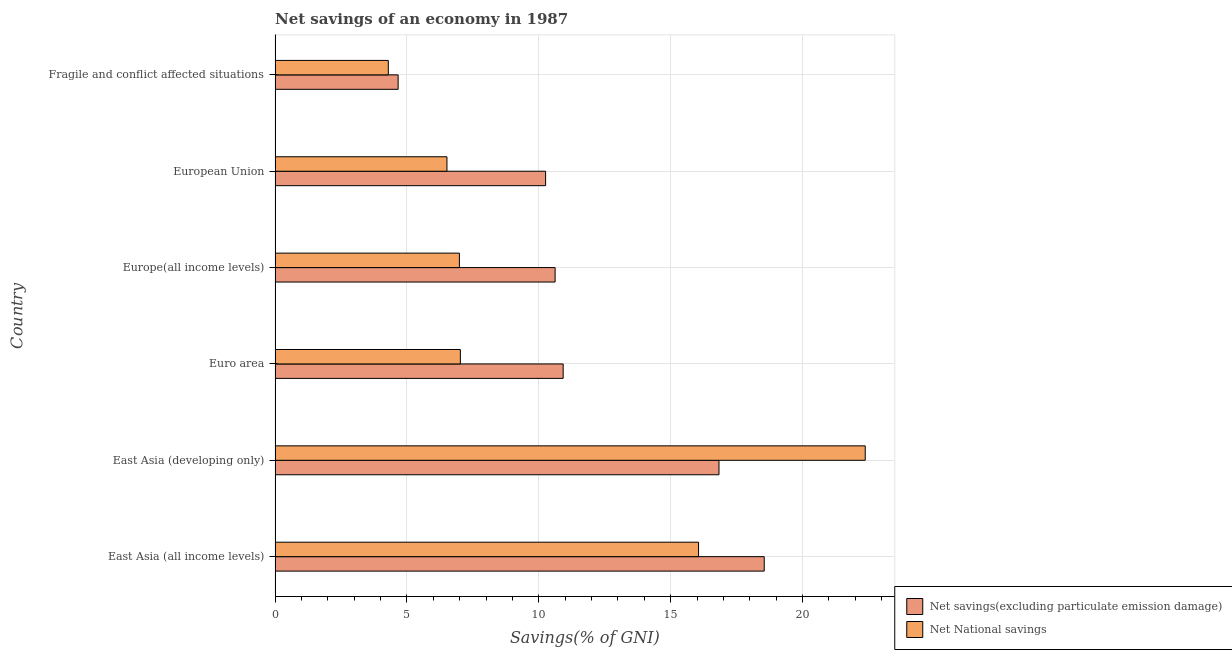How many groups of bars are there?
Ensure brevity in your answer.  6. How many bars are there on the 4th tick from the top?
Keep it short and to the point. 2. How many bars are there on the 3rd tick from the bottom?
Your answer should be compact. 2. What is the label of the 2nd group of bars from the top?
Give a very brief answer. European Union. What is the net national savings in Europe(all income levels)?
Provide a short and direct response. 6.99. Across all countries, what is the maximum net national savings?
Offer a terse response. 22.38. Across all countries, what is the minimum net savings(excluding particulate emission damage)?
Provide a succinct answer. 4.67. In which country was the net national savings maximum?
Ensure brevity in your answer.  East Asia (developing only). In which country was the net savings(excluding particulate emission damage) minimum?
Offer a terse response. Fragile and conflict affected situations. What is the total net savings(excluding particulate emission damage) in the graph?
Your answer should be compact. 71.84. What is the difference between the net national savings in East Asia (developing only) and that in European Union?
Make the answer very short. 15.86. What is the difference between the net national savings in East Asia (developing only) and the net savings(excluding particulate emission damage) in European Union?
Offer a terse response. 12.12. What is the average net national savings per country?
Ensure brevity in your answer.  10.54. What is the difference between the net national savings and net savings(excluding particulate emission damage) in Fragile and conflict affected situations?
Your answer should be very brief. -0.37. In how many countries, is the net savings(excluding particulate emission damage) greater than 18 %?
Keep it short and to the point. 1. What is the ratio of the net savings(excluding particulate emission damage) in East Asia (all income levels) to that in Fragile and conflict affected situations?
Give a very brief answer. 3.98. Is the net savings(excluding particulate emission damage) in East Asia (all income levels) less than that in Euro area?
Your answer should be very brief. No. Is the difference between the net national savings in East Asia (developing only) and Euro area greater than the difference between the net savings(excluding particulate emission damage) in East Asia (developing only) and Euro area?
Your answer should be compact. Yes. What is the difference between the highest and the second highest net savings(excluding particulate emission damage)?
Your answer should be very brief. 1.72. What is the difference between the highest and the lowest net national savings?
Make the answer very short. 18.08. Is the sum of the net savings(excluding particulate emission damage) in East Asia (all income levels) and Europe(all income levels) greater than the maximum net national savings across all countries?
Keep it short and to the point. Yes. What does the 1st bar from the top in East Asia (all income levels) represents?
Offer a very short reply. Net National savings. What does the 1st bar from the bottom in Euro area represents?
Offer a terse response. Net savings(excluding particulate emission damage). How many countries are there in the graph?
Ensure brevity in your answer.  6. What is the difference between two consecutive major ticks on the X-axis?
Offer a very short reply. 5. Are the values on the major ticks of X-axis written in scientific E-notation?
Your response must be concise. No. Does the graph contain any zero values?
Your response must be concise. No. Does the graph contain grids?
Make the answer very short. Yes. Where does the legend appear in the graph?
Provide a succinct answer. Bottom right. How many legend labels are there?
Your answer should be compact. 2. What is the title of the graph?
Give a very brief answer. Net savings of an economy in 1987. What is the label or title of the X-axis?
Provide a succinct answer. Savings(% of GNI). What is the label or title of the Y-axis?
Give a very brief answer. Country. What is the Savings(% of GNI) of Net savings(excluding particulate emission damage) in East Asia (all income levels)?
Your answer should be very brief. 18.55. What is the Savings(% of GNI) of Net National savings in East Asia (all income levels)?
Your answer should be very brief. 16.06. What is the Savings(% of GNI) in Net savings(excluding particulate emission damage) in East Asia (developing only)?
Ensure brevity in your answer.  16.83. What is the Savings(% of GNI) in Net National savings in East Asia (developing only)?
Offer a very short reply. 22.38. What is the Savings(% of GNI) of Net savings(excluding particulate emission damage) in Euro area?
Provide a short and direct response. 10.92. What is the Savings(% of GNI) of Net National savings in Euro area?
Ensure brevity in your answer.  7.02. What is the Savings(% of GNI) in Net savings(excluding particulate emission damage) in Europe(all income levels)?
Ensure brevity in your answer.  10.62. What is the Savings(% of GNI) of Net National savings in Europe(all income levels)?
Your answer should be very brief. 6.99. What is the Savings(% of GNI) in Net savings(excluding particulate emission damage) in European Union?
Your answer should be very brief. 10.26. What is the Savings(% of GNI) of Net National savings in European Union?
Keep it short and to the point. 6.52. What is the Savings(% of GNI) in Net savings(excluding particulate emission damage) in Fragile and conflict affected situations?
Give a very brief answer. 4.67. What is the Savings(% of GNI) of Net National savings in Fragile and conflict affected situations?
Keep it short and to the point. 4.29. Across all countries, what is the maximum Savings(% of GNI) in Net savings(excluding particulate emission damage)?
Make the answer very short. 18.55. Across all countries, what is the maximum Savings(% of GNI) in Net National savings?
Your answer should be compact. 22.38. Across all countries, what is the minimum Savings(% of GNI) in Net savings(excluding particulate emission damage)?
Offer a very short reply. 4.67. Across all countries, what is the minimum Savings(% of GNI) in Net National savings?
Keep it short and to the point. 4.29. What is the total Savings(% of GNI) in Net savings(excluding particulate emission damage) in the graph?
Your response must be concise. 71.84. What is the total Savings(% of GNI) of Net National savings in the graph?
Offer a terse response. 63.25. What is the difference between the Savings(% of GNI) in Net savings(excluding particulate emission damage) in East Asia (all income levels) and that in East Asia (developing only)?
Give a very brief answer. 1.72. What is the difference between the Savings(% of GNI) of Net National savings in East Asia (all income levels) and that in East Asia (developing only)?
Your answer should be very brief. -6.32. What is the difference between the Savings(% of GNI) of Net savings(excluding particulate emission damage) in East Asia (all income levels) and that in Euro area?
Provide a short and direct response. 7.62. What is the difference between the Savings(% of GNI) in Net National savings in East Asia (all income levels) and that in Euro area?
Provide a short and direct response. 9.03. What is the difference between the Savings(% of GNI) of Net savings(excluding particulate emission damage) in East Asia (all income levels) and that in Europe(all income levels)?
Keep it short and to the point. 7.93. What is the difference between the Savings(% of GNI) of Net National savings in East Asia (all income levels) and that in Europe(all income levels)?
Offer a terse response. 9.07. What is the difference between the Savings(% of GNI) in Net savings(excluding particulate emission damage) in East Asia (all income levels) and that in European Union?
Your response must be concise. 8.29. What is the difference between the Savings(% of GNI) in Net National savings in East Asia (all income levels) and that in European Union?
Your response must be concise. 9.54. What is the difference between the Savings(% of GNI) of Net savings(excluding particulate emission damage) in East Asia (all income levels) and that in Fragile and conflict affected situations?
Your answer should be very brief. 13.88. What is the difference between the Savings(% of GNI) of Net National savings in East Asia (all income levels) and that in Fragile and conflict affected situations?
Offer a very short reply. 11.76. What is the difference between the Savings(% of GNI) in Net savings(excluding particulate emission damage) in East Asia (developing only) and that in Euro area?
Make the answer very short. 5.91. What is the difference between the Savings(% of GNI) in Net National savings in East Asia (developing only) and that in Euro area?
Your answer should be compact. 15.35. What is the difference between the Savings(% of GNI) of Net savings(excluding particulate emission damage) in East Asia (developing only) and that in Europe(all income levels)?
Offer a terse response. 6.21. What is the difference between the Savings(% of GNI) of Net National savings in East Asia (developing only) and that in Europe(all income levels)?
Provide a short and direct response. 15.39. What is the difference between the Savings(% of GNI) in Net savings(excluding particulate emission damage) in East Asia (developing only) and that in European Union?
Ensure brevity in your answer.  6.57. What is the difference between the Savings(% of GNI) of Net National savings in East Asia (developing only) and that in European Union?
Your response must be concise. 15.86. What is the difference between the Savings(% of GNI) in Net savings(excluding particulate emission damage) in East Asia (developing only) and that in Fragile and conflict affected situations?
Your answer should be compact. 12.17. What is the difference between the Savings(% of GNI) in Net National savings in East Asia (developing only) and that in Fragile and conflict affected situations?
Provide a succinct answer. 18.08. What is the difference between the Savings(% of GNI) in Net savings(excluding particulate emission damage) in Euro area and that in Europe(all income levels)?
Provide a succinct answer. 0.31. What is the difference between the Savings(% of GNI) in Net National savings in Euro area and that in Europe(all income levels)?
Your answer should be very brief. 0.04. What is the difference between the Savings(% of GNI) in Net savings(excluding particulate emission damage) in Euro area and that in European Union?
Offer a terse response. 0.67. What is the difference between the Savings(% of GNI) of Net National savings in Euro area and that in European Union?
Keep it short and to the point. 0.51. What is the difference between the Savings(% of GNI) of Net savings(excluding particulate emission damage) in Euro area and that in Fragile and conflict affected situations?
Offer a very short reply. 6.26. What is the difference between the Savings(% of GNI) of Net National savings in Euro area and that in Fragile and conflict affected situations?
Keep it short and to the point. 2.73. What is the difference between the Savings(% of GNI) in Net savings(excluding particulate emission damage) in Europe(all income levels) and that in European Union?
Offer a very short reply. 0.36. What is the difference between the Savings(% of GNI) of Net National savings in Europe(all income levels) and that in European Union?
Provide a succinct answer. 0.47. What is the difference between the Savings(% of GNI) in Net savings(excluding particulate emission damage) in Europe(all income levels) and that in Fragile and conflict affected situations?
Your answer should be very brief. 5.95. What is the difference between the Savings(% of GNI) in Net National savings in Europe(all income levels) and that in Fragile and conflict affected situations?
Give a very brief answer. 2.7. What is the difference between the Savings(% of GNI) in Net savings(excluding particulate emission damage) in European Union and that in Fragile and conflict affected situations?
Provide a short and direct response. 5.59. What is the difference between the Savings(% of GNI) of Net National savings in European Union and that in Fragile and conflict affected situations?
Offer a very short reply. 2.22. What is the difference between the Savings(% of GNI) in Net savings(excluding particulate emission damage) in East Asia (all income levels) and the Savings(% of GNI) in Net National savings in East Asia (developing only)?
Provide a succinct answer. -3.83. What is the difference between the Savings(% of GNI) of Net savings(excluding particulate emission damage) in East Asia (all income levels) and the Savings(% of GNI) of Net National savings in Euro area?
Provide a succinct answer. 11.52. What is the difference between the Savings(% of GNI) of Net savings(excluding particulate emission damage) in East Asia (all income levels) and the Savings(% of GNI) of Net National savings in Europe(all income levels)?
Provide a short and direct response. 11.56. What is the difference between the Savings(% of GNI) of Net savings(excluding particulate emission damage) in East Asia (all income levels) and the Savings(% of GNI) of Net National savings in European Union?
Your response must be concise. 12.03. What is the difference between the Savings(% of GNI) of Net savings(excluding particulate emission damage) in East Asia (all income levels) and the Savings(% of GNI) of Net National savings in Fragile and conflict affected situations?
Offer a very short reply. 14.25. What is the difference between the Savings(% of GNI) of Net savings(excluding particulate emission damage) in East Asia (developing only) and the Savings(% of GNI) of Net National savings in Euro area?
Make the answer very short. 9.81. What is the difference between the Savings(% of GNI) in Net savings(excluding particulate emission damage) in East Asia (developing only) and the Savings(% of GNI) in Net National savings in Europe(all income levels)?
Provide a succinct answer. 9.84. What is the difference between the Savings(% of GNI) of Net savings(excluding particulate emission damage) in East Asia (developing only) and the Savings(% of GNI) of Net National savings in European Union?
Offer a very short reply. 10.31. What is the difference between the Savings(% of GNI) in Net savings(excluding particulate emission damage) in East Asia (developing only) and the Savings(% of GNI) in Net National savings in Fragile and conflict affected situations?
Offer a terse response. 12.54. What is the difference between the Savings(% of GNI) in Net savings(excluding particulate emission damage) in Euro area and the Savings(% of GNI) in Net National savings in Europe(all income levels)?
Ensure brevity in your answer.  3.93. What is the difference between the Savings(% of GNI) of Net savings(excluding particulate emission damage) in Euro area and the Savings(% of GNI) of Net National savings in European Union?
Your answer should be compact. 4.41. What is the difference between the Savings(% of GNI) of Net savings(excluding particulate emission damage) in Euro area and the Savings(% of GNI) of Net National savings in Fragile and conflict affected situations?
Your answer should be compact. 6.63. What is the difference between the Savings(% of GNI) of Net savings(excluding particulate emission damage) in Europe(all income levels) and the Savings(% of GNI) of Net National savings in European Union?
Your answer should be compact. 4.1. What is the difference between the Savings(% of GNI) of Net savings(excluding particulate emission damage) in Europe(all income levels) and the Savings(% of GNI) of Net National savings in Fragile and conflict affected situations?
Your response must be concise. 6.32. What is the difference between the Savings(% of GNI) in Net savings(excluding particulate emission damage) in European Union and the Savings(% of GNI) in Net National savings in Fragile and conflict affected situations?
Ensure brevity in your answer.  5.96. What is the average Savings(% of GNI) of Net savings(excluding particulate emission damage) per country?
Your answer should be compact. 11.97. What is the average Savings(% of GNI) of Net National savings per country?
Keep it short and to the point. 10.54. What is the difference between the Savings(% of GNI) of Net savings(excluding particulate emission damage) and Savings(% of GNI) of Net National savings in East Asia (all income levels)?
Keep it short and to the point. 2.49. What is the difference between the Savings(% of GNI) in Net savings(excluding particulate emission damage) and Savings(% of GNI) in Net National savings in East Asia (developing only)?
Your answer should be compact. -5.54. What is the difference between the Savings(% of GNI) of Net savings(excluding particulate emission damage) and Savings(% of GNI) of Net National savings in Euro area?
Offer a terse response. 3.9. What is the difference between the Savings(% of GNI) in Net savings(excluding particulate emission damage) and Savings(% of GNI) in Net National savings in Europe(all income levels)?
Give a very brief answer. 3.63. What is the difference between the Savings(% of GNI) in Net savings(excluding particulate emission damage) and Savings(% of GNI) in Net National savings in European Union?
Make the answer very short. 3.74. What is the difference between the Savings(% of GNI) in Net savings(excluding particulate emission damage) and Savings(% of GNI) in Net National savings in Fragile and conflict affected situations?
Your answer should be compact. 0.37. What is the ratio of the Savings(% of GNI) of Net savings(excluding particulate emission damage) in East Asia (all income levels) to that in East Asia (developing only)?
Keep it short and to the point. 1.1. What is the ratio of the Savings(% of GNI) of Net National savings in East Asia (all income levels) to that in East Asia (developing only)?
Offer a very short reply. 0.72. What is the ratio of the Savings(% of GNI) of Net savings(excluding particulate emission damage) in East Asia (all income levels) to that in Euro area?
Your answer should be compact. 1.7. What is the ratio of the Savings(% of GNI) in Net National savings in East Asia (all income levels) to that in Euro area?
Ensure brevity in your answer.  2.29. What is the ratio of the Savings(% of GNI) in Net savings(excluding particulate emission damage) in East Asia (all income levels) to that in Europe(all income levels)?
Make the answer very short. 1.75. What is the ratio of the Savings(% of GNI) of Net National savings in East Asia (all income levels) to that in Europe(all income levels)?
Keep it short and to the point. 2.3. What is the ratio of the Savings(% of GNI) in Net savings(excluding particulate emission damage) in East Asia (all income levels) to that in European Union?
Your answer should be compact. 1.81. What is the ratio of the Savings(% of GNI) of Net National savings in East Asia (all income levels) to that in European Union?
Ensure brevity in your answer.  2.46. What is the ratio of the Savings(% of GNI) of Net savings(excluding particulate emission damage) in East Asia (all income levels) to that in Fragile and conflict affected situations?
Make the answer very short. 3.98. What is the ratio of the Savings(% of GNI) in Net National savings in East Asia (all income levels) to that in Fragile and conflict affected situations?
Offer a terse response. 3.74. What is the ratio of the Savings(% of GNI) of Net savings(excluding particulate emission damage) in East Asia (developing only) to that in Euro area?
Your answer should be very brief. 1.54. What is the ratio of the Savings(% of GNI) of Net National savings in East Asia (developing only) to that in Euro area?
Your answer should be very brief. 3.19. What is the ratio of the Savings(% of GNI) in Net savings(excluding particulate emission damage) in East Asia (developing only) to that in Europe(all income levels)?
Ensure brevity in your answer.  1.59. What is the ratio of the Savings(% of GNI) of Net National savings in East Asia (developing only) to that in Europe(all income levels)?
Offer a terse response. 3.2. What is the ratio of the Savings(% of GNI) in Net savings(excluding particulate emission damage) in East Asia (developing only) to that in European Union?
Your response must be concise. 1.64. What is the ratio of the Savings(% of GNI) of Net National savings in East Asia (developing only) to that in European Union?
Give a very brief answer. 3.43. What is the ratio of the Savings(% of GNI) in Net savings(excluding particulate emission damage) in East Asia (developing only) to that in Fragile and conflict affected situations?
Your answer should be compact. 3.61. What is the ratio of the Savings(% of GNI) in Net National savings in East Asia (developing only) to that in Fragile and conflict affected situations?
Offer a terse response. 5.21. What is the ratio of the Savings(% of GNI) of Net savings(excluding particulate emission damage) in Euro area to that in Europe(all income levels)?
Your answer should be very brief. 1.03. What is the ratio of the Savings(% of GNI) of Net savings(excluding particulate emission damage) in Euro area to that in European Union?
Offer a terse response. 1.06. What is the ratio of the Savings(% of GNI) of Net National savings in Euro area to that in European Union?
Your response must be concise. 1.08. What is the ratio of the Savings(% of GNI) of Net savings(excluding particulate emission damage) in Euro area to that in Fragile and conflict affected situations?
Offer a very short reply. 2.34. What is the ratio of the Savings(% of GNI) of Net National savings in Euro area to that in Fragile and conflict affected situations?
Your answer should be compact. 1.64. What is the ratio of the Savings(% of GNI) in Net savings(excluding particulate emission damage) in Europe(all income levels) to that in European Union?
Your answer should be very brief. 1.04. What is the ratio of the Savings(% of GNI) of Net National savings in Europe(all income levels) to that in European Union?
Make the answer very short. 1.07. What is the ratio of the Savings(% of GNI) in Net savings(excluding particulate emission damage) in Europe(all income levels) to that in Fragile and conflict affected situations?
Provide a short and direct response. 2.28. What is the ratio of the Savings(% of GNI) in Net National savings in Europe(all income levels) to that in Fragile and conflict affected situations?
Your answer should be very brief. 1.63. What is the ratio of the Savings(% of GNI) in Net savings(excluding particulate emission damage) in European Union to that in Fragile and conflict affected situations?
Provide a succinct answer. 2.2. What is the ratio of the Savings(% of GNI) in Net National savings in European Union to that in Fragile and conflict affected situations?
Make the answer very short. 1.52. What is the difference between the highest and the second highest Savings(% of GNI) in Net savings(excluding particulate emission damage)?
Give a very brief answer. 1.72. What is the difference between the highest and the second highest Savings(% of GNI) in Net National savings?
Your response must be concise. 6.32. What is the difference between the highest and the lowest Savings(% of GNI) in Net savings(excluding particulate emission damage)?
Offer a very short reply. 13.88. What is the difference between the highest and the lowest Savings(% of GNI) of Net National savings?
Your answer should be very brief. 18.08. 